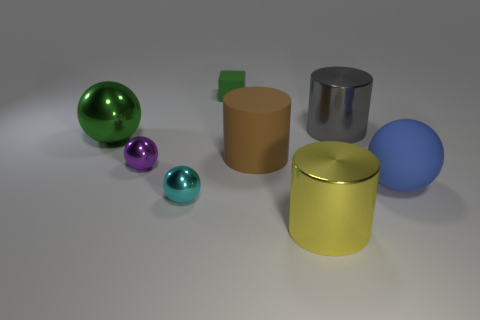Are there an equal number of large gray shiny cylinders that are in front of the big yellow thing and brown cylinders that are left of the large metal ball?
Provide a short and direct response. Yes. What is the color of the big matte thing that is the same shape as the yellow metal object?
Provide a succinct answer. Brown. Is there any other thing that has the same shape as the tiny matte thing?
Your answer should be compact. No. There is a big ball behind the brown object; is it the same color as the tiny cube?
Make the answer very short. Yes. The green object that is the same shape as the cyan object is what size?
Ensure brevity in your answer.  Large. How many small blue things are made of the same material as the large yellow cylinder?
Your answer should be compact. 0. Are there any metallic objects on the right side of the tiny metal thing that is in front of the ball to the right of the gray metallic cylinder?
Offer a very short reply. Yes. What shape is the tiny matte object?
Offer a terse response. Cube. Do the large ball in front of the large green shiny ball and the ball in front of the blue rubber thing have the same material?
Provide a short and direct response. No. What number of tiny rubber objects are the same color as the rubber cylinder?
Offer a very short reply. 0. 